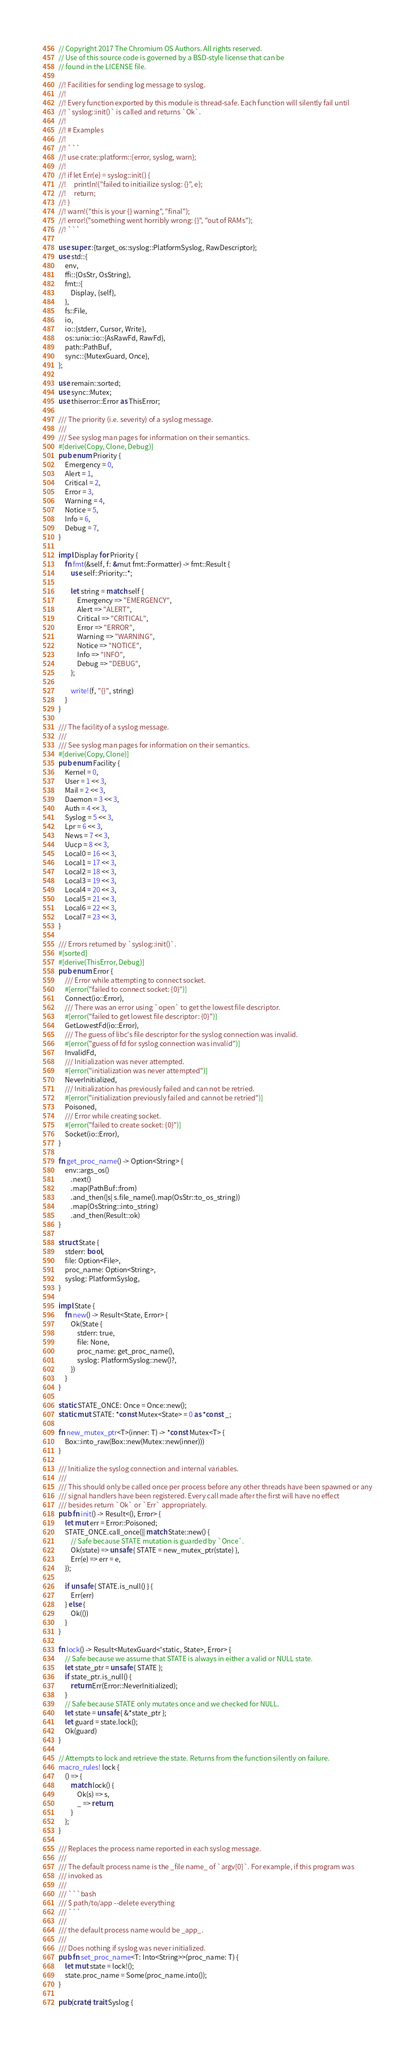Convert code to text. <code><loc_0><loc_0><loc_500><loc_500><_Rust_>// Copyright 2017 The Chromium OS Authors. All rights reserved.
// Use of this source code is governed by a BSD-style license that can be
// found in the LICENSE file.

//! Facilities for sending log message to syslog.
//!
//! Every function exported by this module is thread-safe. Each function will silently fail until
//! `syslog::init()` is called and returns `Ok`.
//!
//! # Examples
//!
//! ```
//! use crate::platform::{error, syslog, warn};
//!
//! if let Err(e) = syslog::init() {
//!     println!("failed to initiailize syslog: {}", e);
//!     return;
//! }
//! warn!("this is your {} warning", "final");
//! error!("something went horribly wrong: {}", "out of RAMs");
//! ```

use super::{target_os::syslog::PlatformSyslog, RawDescriptor};
use std::{
    env,
    ffi::{OsStr, OsString},
    fmt::{
        Display, {self},
    },
    fs::File,
    io,
    io::{stderr, Cursor, Write},
    os::unix::io::{AsRawFd, RawFd},
    path::PathBuf,
    sync::{MutexGuard, Once},
};

use remain::sorted;
use sync::Mutex;
use thiserror::Error as ThisError;

/// The priority (i.e. severity) of a syslog message.
///
/// See syslog man pages for information on their semantics.
#[derive(Copy, Clone, Debug)]
pub enum Priority {
    Emergency = 0,
    Alert = 1,
    Critical = 2,
    Error = 3,
    Warning = 4,
    Notice = 5,
    Info = 6,
    Debug = 7,
}

impl Display for Priority {
    fn fmt(&self, f: &mut fmt::Formatter) -> fmt::Result {
        use self::Priority::*;

        let string = match self {
            Emergency => "EMERGENCY",
            Alert => "ALERT",
            Critical => "CRITICAL",
            Error => "ERROR",
            Warning => "WARNING",
            Notice => "NOTICE",
            Info => "INFO",
            Debug => "DEBUG",
        };

        write!(f, "{}", string)
    }
}

/// The facility of a syslog message.
///
/// See syslog man pages for information on their semantics.
#[derive(Copy, Clone)]
pub enum Facility {
    Kernel = 0,
    User = 1 << 3,
    Mail = 2 << 3,
    Daemon = 3 << 3,
    Auth = 4 << 3,
    Syslog = 5 << 3,
    Lpr = 6 << 3,
    News = 7 << 3,
    Uucp = 8 << 3,
    Local0 = 16 << 3,
    Local1 = 17 << 3,
    Local2 = 18 << 3,
    Local3 = 19 << 3,
    Local4 = 20 << 3,
    Local5 = 21 << 3,
    Local6 = 22 << 3,
    Local7 = 23 << 3,
}

/// Errors returned by `syslog::init()`.
#[sorted]
#[derive(ThisError, Debug)]
pub enum Error {
    /// Error while attempting to connect socket.
    #[error("failed to connect socket: {0}")]
    Connect(io::Error),
    /// There was an error using `open` to get the lowest file descriptor.
    #[error("failed to get lowest file descriptor: {0}")]
    GetLowestFd(io::Error),
    /// The guess of libc's file descriptor for the syslog connection was invalid.
    #[error("guess of fd for syslog connection was invalid")]
    InvalidFd,
    /// Initialization was never attempted.
    #[error("initialization was never attempted")]
    NeverInitialized,
    /// Initialization has previously failed and can not be retried.
    #[error("initialization previously failed and cannot be retried")]
    Poisoned,
    /// Error while creating socket.
    #[error("failed to create socket: {0}")]
    Socket(io::Error),
}

fn get_proc_name() -> Option<String> {
    env::args_os()
        .next()
        .map(PathBuf::from)
        .and_then(|s| s.file_name().map(OsStr::to_os_string))
        .map(OsString::into_string)
        .and_then(Result::ok)
}

struct State {
    stderr: bool,
    file: Option<File>,
    proc_name: Option<String>,
    syslog: PlatformSyslog,
}

impl State {
    fn new() -> Result<State, Error> {
        Ok(State {
            stderr: true,
            file: None,
            proc_name: get_proc_name(),
            syslog: PlatformSyslog::new()?,
        })
    }
}

static STATE_ONCE: Once = Once::new();
static mut STATE: *const Mutex<State> = 0 as *const _;

fn new_mutex_ptr<T>(inner: T) -> *const Mutex<T> {
    Box::into_raw(Box::new(Mutex::new(inner)))
}

/// Initialize the syslog connection and internal variables.
///
/// This should only be called once per process before any other threads have been spawned or any
/// signal handlers have been registered. Every call made after the first will have no effect
/// besides return `Ok` or `Err` appropriately.
pub fn init() -> Result<(), Error> {
    let mut err = Error::Poisoned;
    STATE_ONCE.call_once(|| match State::new() {
        // Safe because STATE mutation is guarded by `Once`.
        Ok(state) => unsafe { STATE = new_mutex_ptr(state) },
        Err(e) => err = e,
    });

    if unsafe { STATE.is_null() } {
        Err(err)
    } else {
        Ok(())
    }
}

fn lock() -> Result<MutexGuard<'static, State>, Error> {
    // Safe because we assume that STATE is always in either a valid or NULL state.
    let state_ptr = unsafe { STATE };
    if state_ptr.is_null() {
        return Err(Error::NeverInitialized);
    }
    // Safe because STATE only mutates once and we checked for NULL.
    let state = unsafe { &*state_ptr };
    let guard = state.lock();
    Ok(guard)
}

// Attempts to lock and retrieve the state. Returns from the function silently on failure.
macro_rules! lock {
    () => {
        match lock() {
            Ok(s) => s,
            _ => return,
        }
    };
}

/// Replaces the process name reported in each syslog message.
///
/// The default process name is the _file name_ of `argv[0]`. For example, if this program was
/// invoked as
///
/// ```bash
/// $ path/to/app --delete everything
/// ```
///
/// the default process name would be _app_.
///
/// Does nothing if syslog was never initialized.
pub fn set_proc_name<T: Into<String>>(proc_name: T) {
    let mut state = lock!();
    state.proc_name = Some(proc_name.into());
}

pub(crate) trait Syslog {</code> 